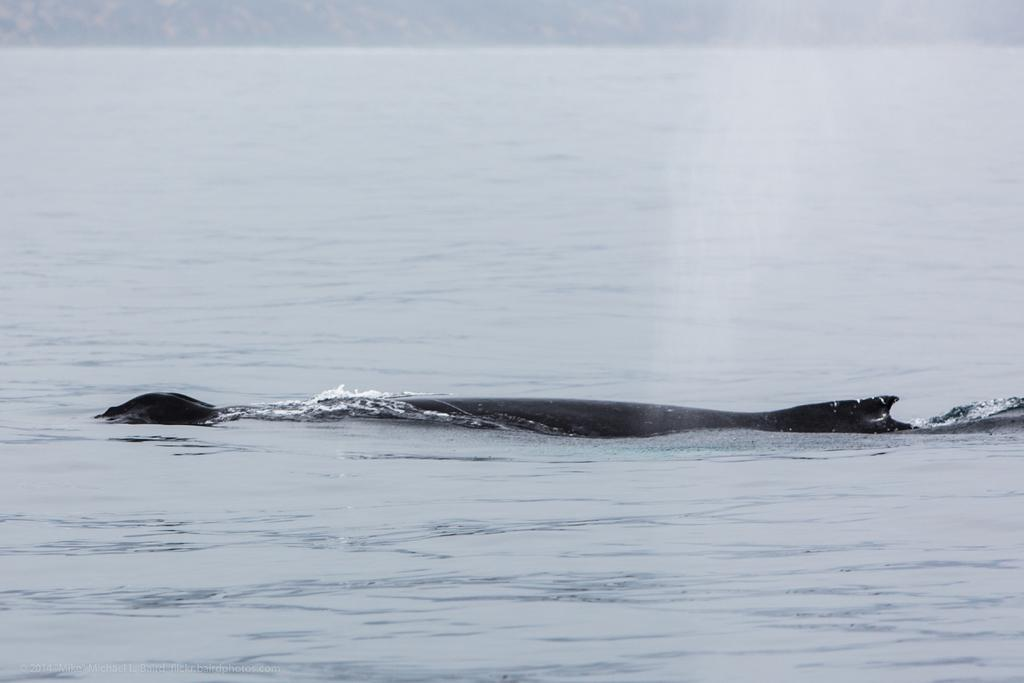What is the person in the image holding? The person is holding a phone. Is there anyone else in the image? Yes, there is another person in the image. What is the second person holding? The second person is holding a book. Can you describe the setting of the image? The setting is not described in the facts provided. What color of paint is being used by the person in the image? There is no mention of paint in the image, so it cannot be determined what color of paint is being used. 